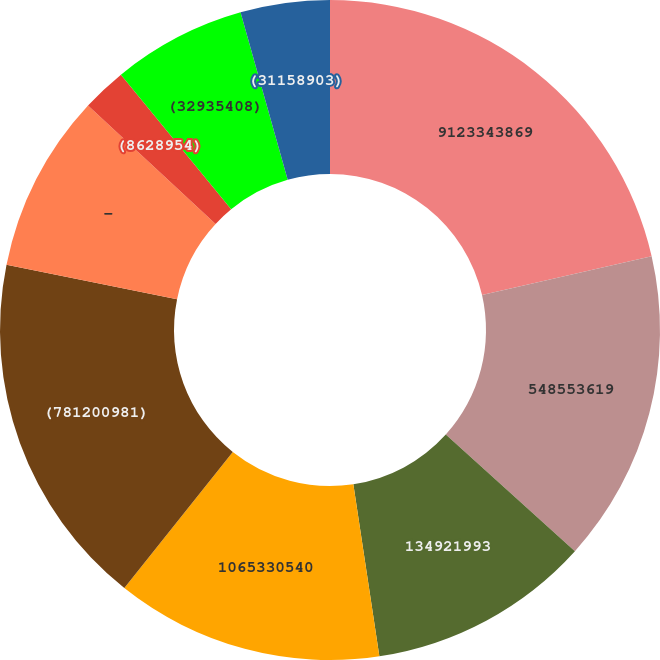Convert chart. <chart><loc_0><loc_0><loc_500><loc_500><pie_chart><fcel>2014<fcel>9123343869<fcel>548553619<fcel>134921993<fcel>1065330540<fcel>(781200981)<fcel>-<fcel>(8628954)<fcel>(32935408)<fcel>(31158903)<nl><fcel>0.0%<fcel>21.41%<fcel>15.28%<fcel>10.92%<fcel>13.1%<fcel>17.46%<fcel>8.73%<fcel>2.18%<fcel>6.55%<fcel>4.37%<nl></chart> 